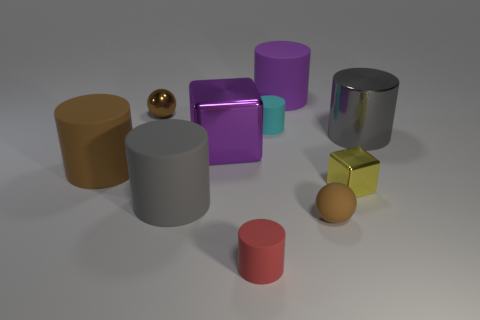Subtract all purple cylinders. How many cylinders are left? 5 Subtract all tiny cyan matte cylinders. How many cylinders are left? 5 Subtract all blue cylinders. Subtract all blue balls. How many cylinders are left? 6 Subtract all balls. How many objects are left? 8 Subtract all tiny metallic cubes. Subtract all big purple metal objects. How many objects are left? 8 Add 2 brown cylinders. How many brown cylinders are left? 3 Add 9 small purple metal things. How many small purple metal things exist? 9 Subtract 0 yellow cylinders. How many objects are left? 10 